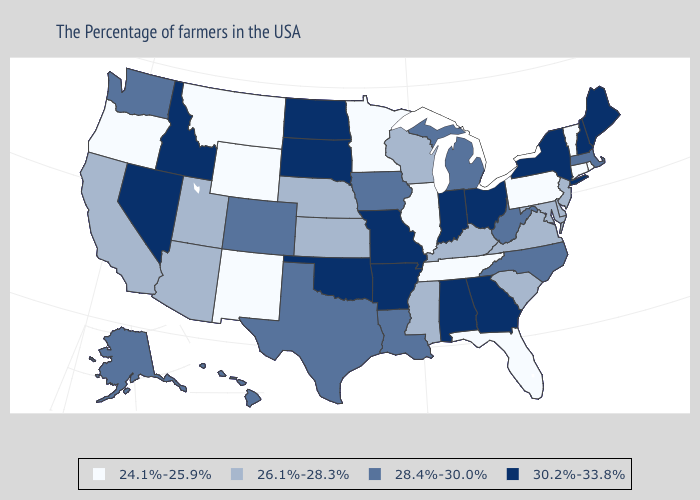Which states hav the highest value in the Northeast?
Give a very brief answer. Maine, New Hampshire, New York. Among the states that border Georgia , which have the lowest value?
Answer briefly. Florida, Tennessee. Does Nebraska have the same value as Tennessee?
Short answer required. No. Which states have the highest value in the USA?
Quick response, please. Maine, New Hampshire, New York, Ohio, Georgia, Indiana, Alabama, Missouri, Arkansas, Oklahoma, South Dakota, North Dakota, Idaho, Nevada. What is the highest value in states that border Kansas?
Be succinct. 30.2%-33.8%. What is the value of Rhode Island?
Keep it brief. 24.1%-25.9%. Is the legend a continuous bar?
Write a very short answer. No. What is the lowest value in states that border Minnesota?
Be succinct. 26.1%-28.3%. Does Iowa have the same value as Pennsylvania?
Be succinct. No. How many symbols are there in the legend?
Answer briefly. 4. What is the value of Connecticut?
Quick response, please. 24.1%-25.9%. Name the states that have a value in the range 28.4%-30.0%?
Be succinct. Massachusetts, North Carolina, West Virginia, Michigan, Louisiana, Iowa, Texas, Colorado, Washington, Alaska, Hawaii. Does Oregon have the highest value in the West?
Concise answer only. No. Name the states that have a value in the range 24.1%-25.9%?
Concise answer only. Rhode Island, Vermont, Connecticut, Pennsylvania, Florida, Tennessee, Illinois, Minnesota, Wyoming, New Mexico, Montana, Oregon. Name the states that have a value in the range 30.2%-33.8%?
Write a very short answer. Maine, New Hampshire, New York, Ohio, Georgia, Indiana, Alabama, Missouri, Arkansas, Oklahoma, South Dakota, North Dakota, Idaho, Nevada. 